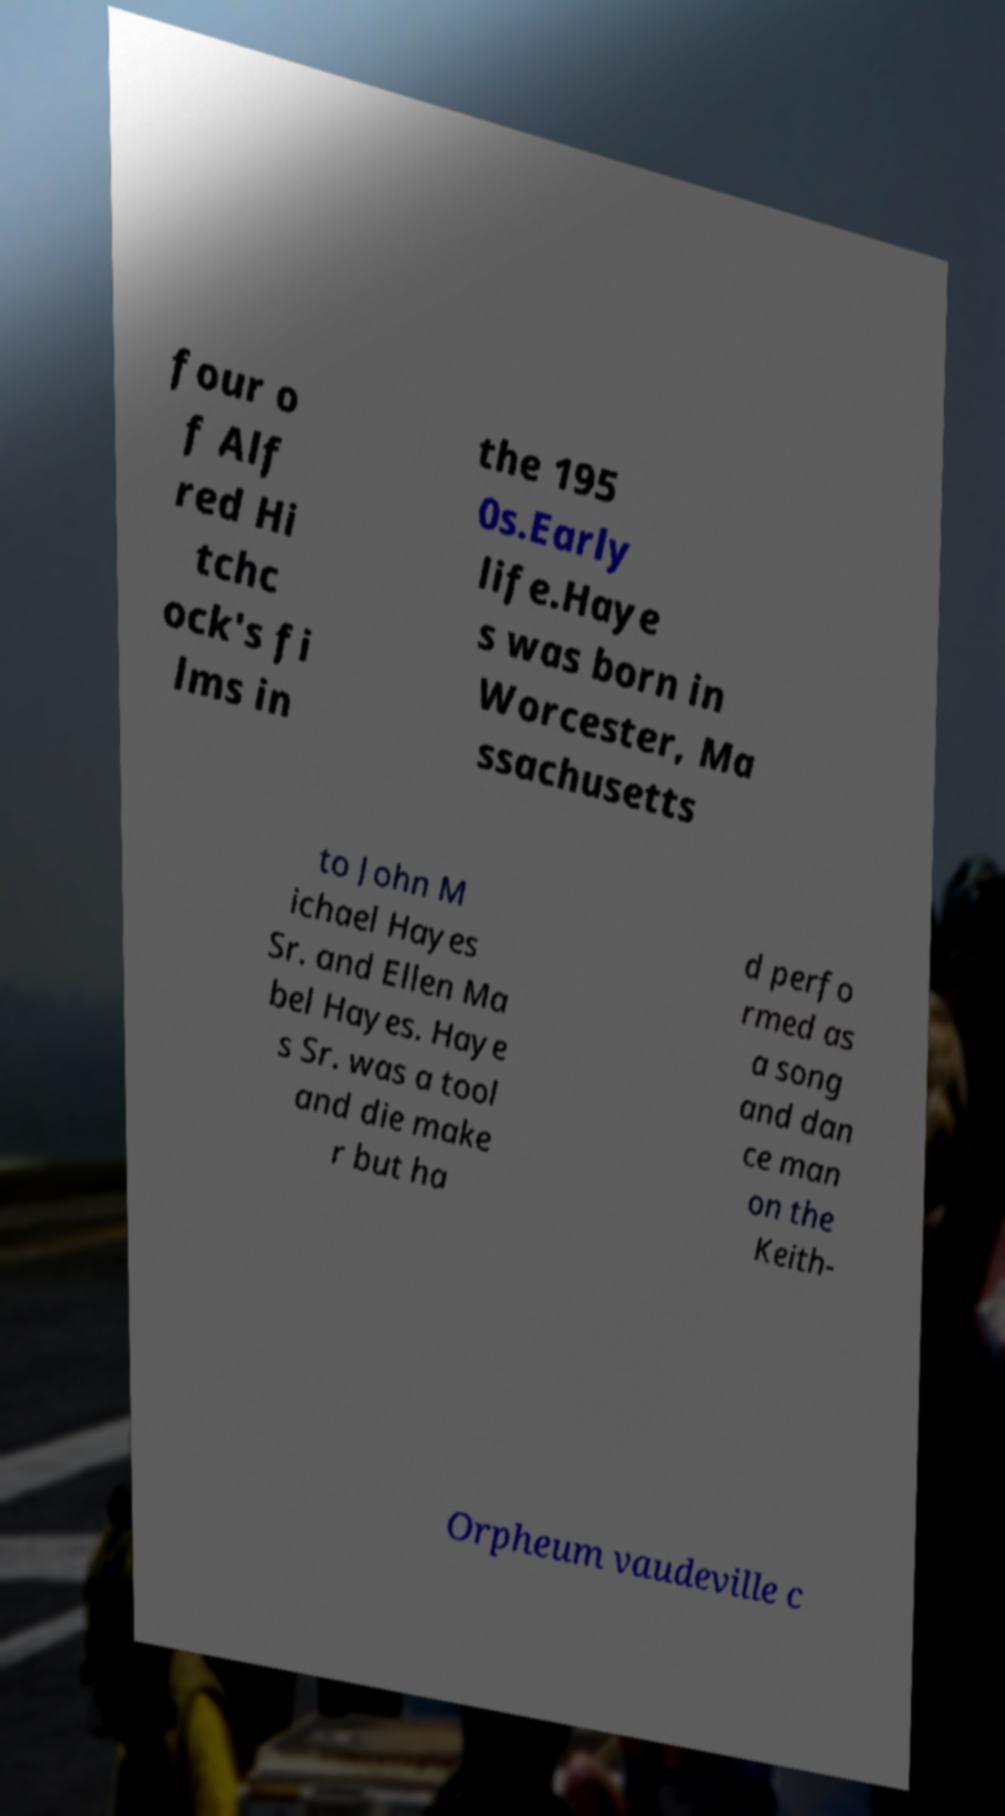I need the written content from this picture converted into text. Can you do that? four o f Alf red Hi tchc ock's fi lms in the 195 0s.Early life.Haye s was born in Worcester, Ma ssachusetts to John M ichael Hayes Sr. and Ellen Ma bel Hayes. Haye s Sr. was a tool and die make r but ha d perfo rmed as a song and dan ce man on the Keith- Orpheum vaudeville c 